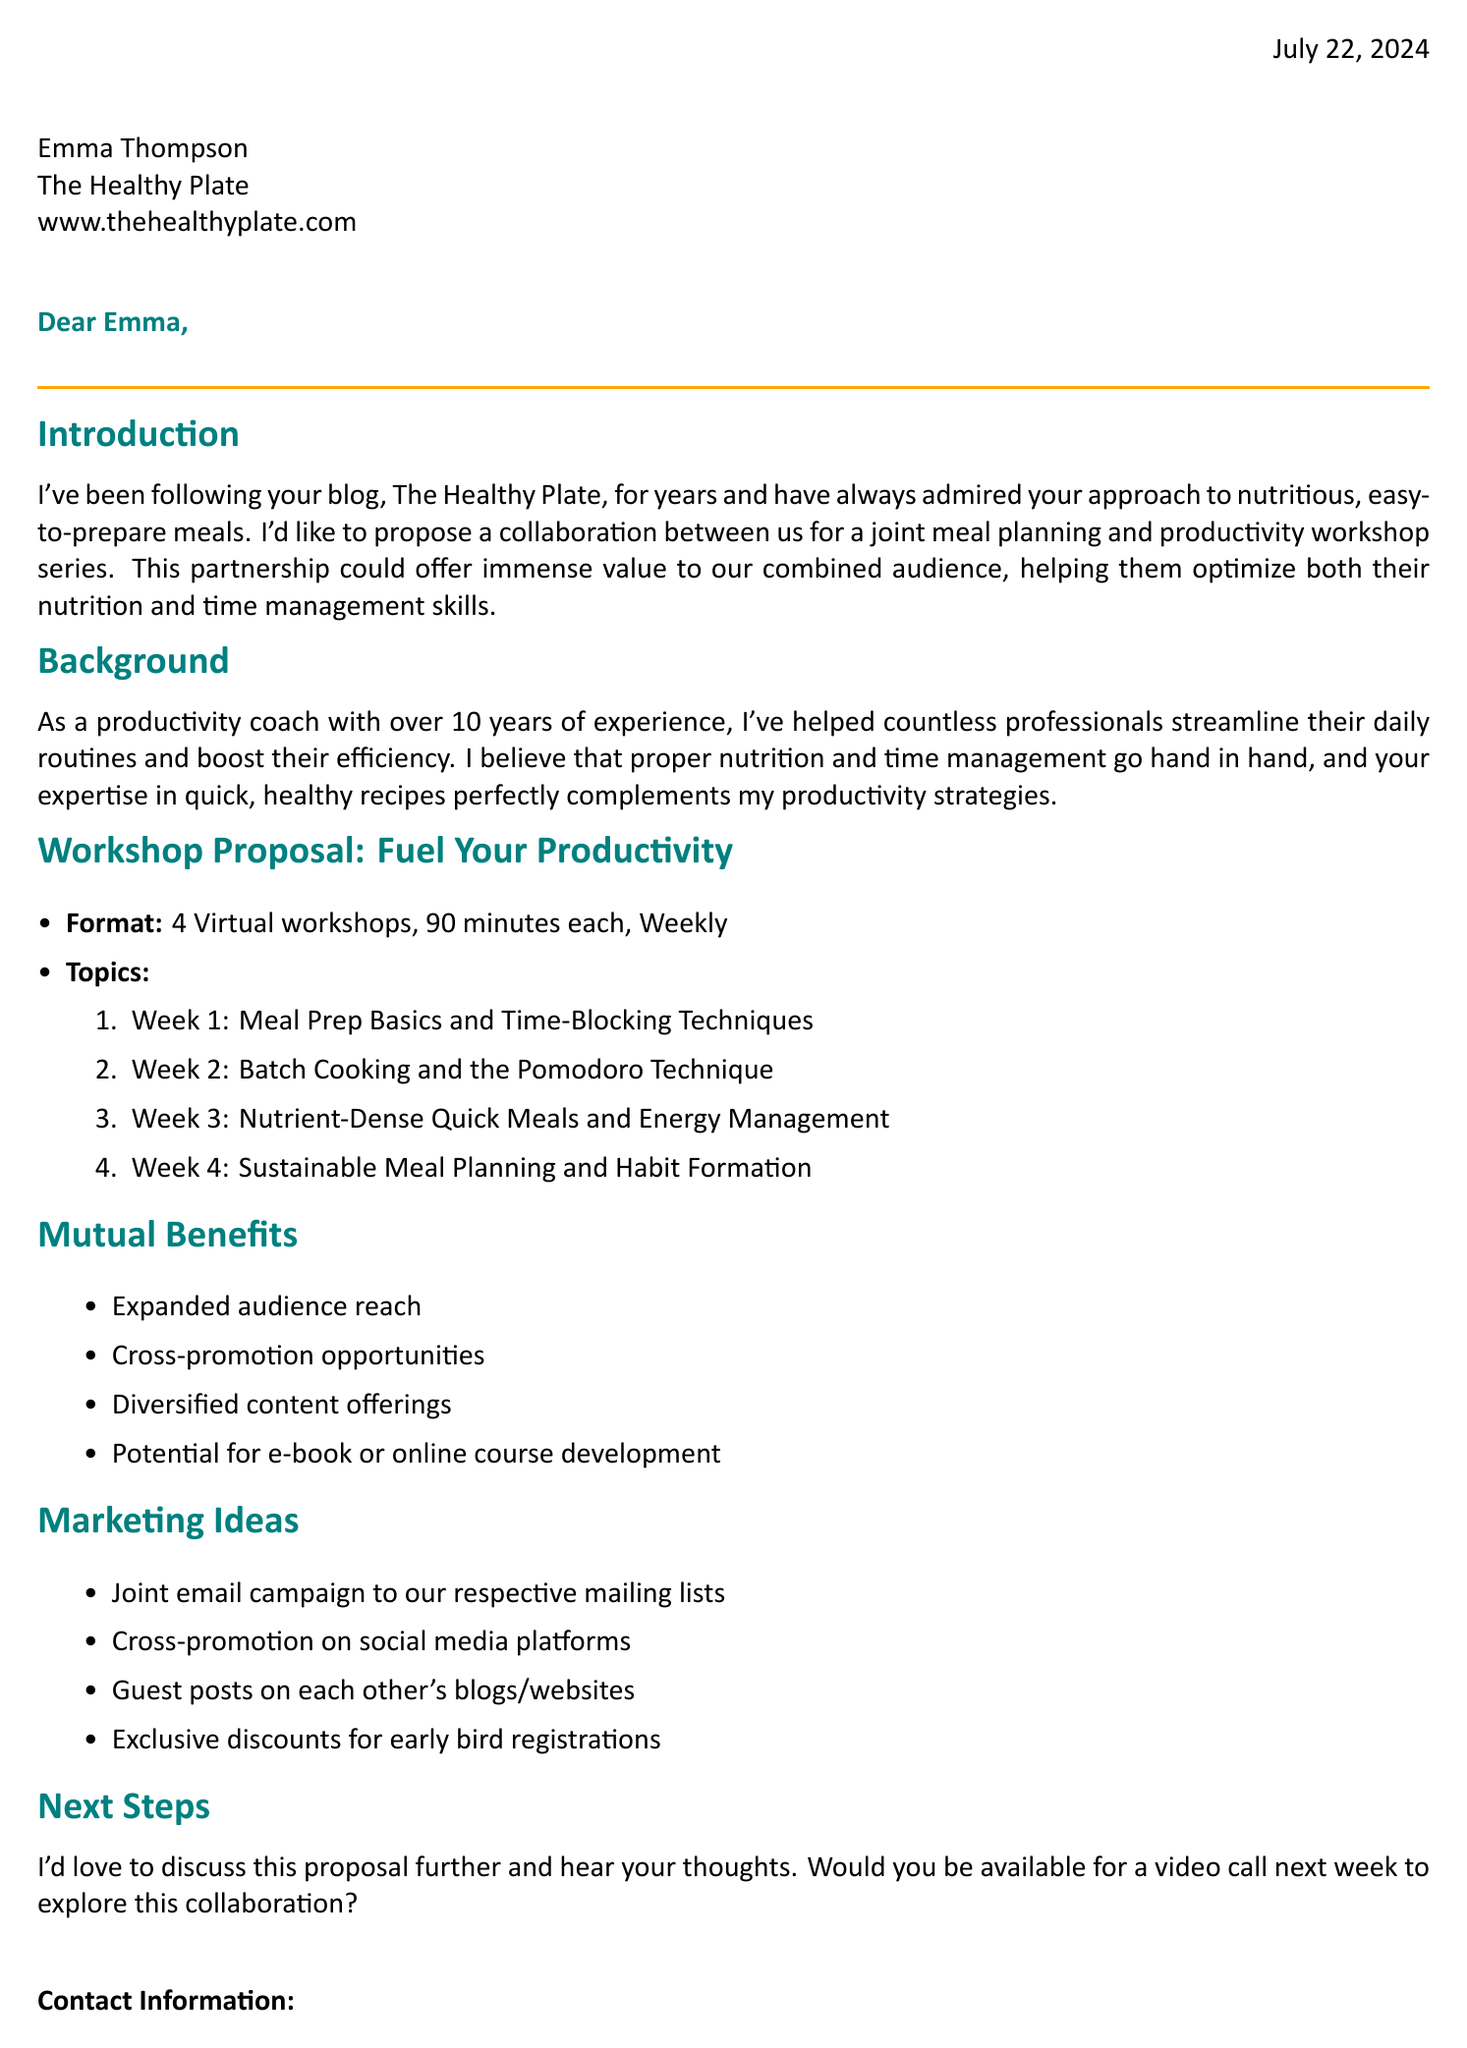What is the title of the workshop series? The title of the workshop series is mentioned directly in the proposal section.
Answer: Fuel Your Productivity: Meal Planning for Busy Professionals Who is the sender of the letter? The sender's name is clearly stated at the beginning of the letter.
Answer: Sarah Johnson How many sessions are proposed for the workshop series? The number of sessions is specified in the workshop proposal section.
Answer: 4 What is the duration of each workshop session? The duration is indicated under the workshop proposal details.
Answer: 90 minutes What is the frequency of the workshops? The frequency of the workshops is stated directly in the proposal section.
Answer: Weekly What is the primary benefit of the proposed collaboration? The primary benefit is expressed in the introduction paragraph of the letter.
Answer: Optimize both their nutrition and time management skills What is one marketing idea mentioned in the document? A marketing idea is listed under the marketing ideas section.
Answer: Joint email campaign to our respective mailing lists What method is suggested for energy management? The document describes a specific topic that focuses on energy management.
Answer: Nutrient-Dense Quick Meals and Energy Management 